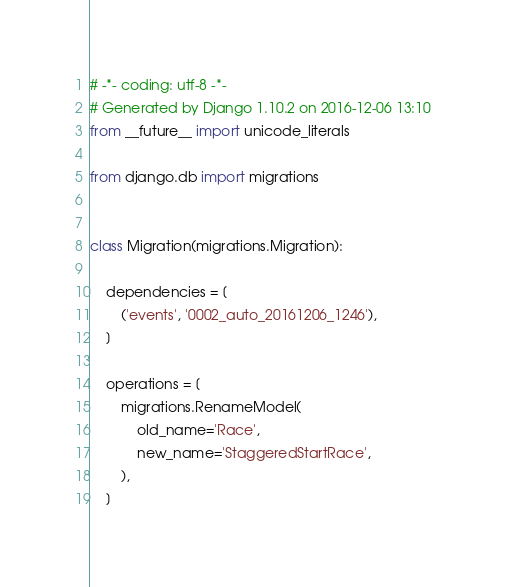Convert code to text. <code><loc_0><loc_0><loc_500><loc_500><_Python_># -*- coding: utf-8 -*-
# Generated by Django 1.10.2 on 2016-12-06 13:10
from __future__ import unicode_literals

from django.db import migrations


class Migration(migrations.Migration):

    dependencies = [
        ('events', '0002_auto_20161206_1246'),
    ]

    operations = [
        migrations.RenameModel(
            old_name='Race',
            new_name='StaggeredStartRace',
        ),
    ]
</code> 